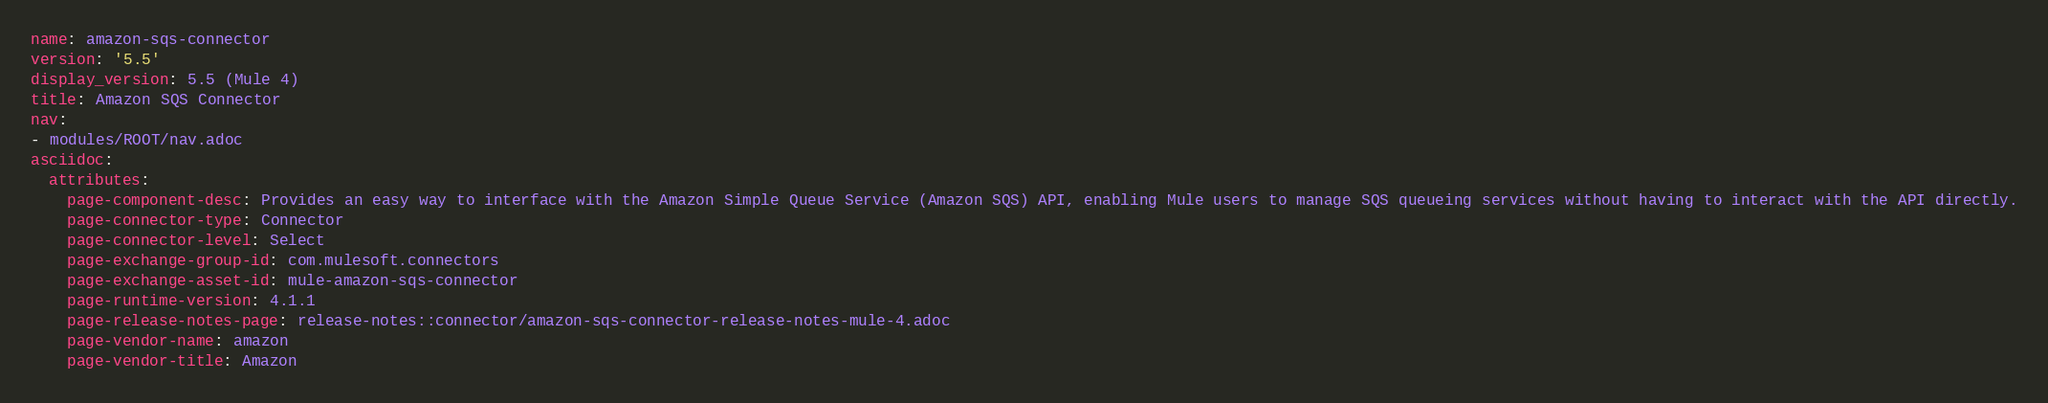<code> <loc_0><loc_0><loc_500><loc_500><_YAML_>name: amazon-sqs-connector
version: '5.5'
display_version: 5.5 (Mule 4)
title: Amazon SQS Connector
nav:
- modules/ROOT/nav.adoc
asciidoc:
  attributes:
    page-component-desc: Provides an easy way to interface with the Amazon Simple Queue Service (Amazon SQS) API, enabling Mule users to manage SQS queueing services without having to interact with the API directly.
    page-connector-type: Connector
    page-connector-level: Select
    page-exchange-group-id: com.mulesoft.connectors
    page-exchange-asset-id: mule-amazon-sqs-connector
    page-runtime-version: 4.1.1
    page-release-notes-page: release-notes::connector/amazon-sqs-connector-release-notes-mule-4.adoc
    page-vendor-name: amazon
    page-vendor-title: Amazon
</code> 